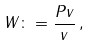Convert formula to latex. <formula><loc_0><loc_0><loc_500><loc_500>W \colon = \frac { P v } { v } \, ,</formula> 